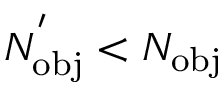<formula> <loc_0><loc_0><loc_500><loc_500>N _ { o b j } ^ { ^ { \prime } } < N _ { o b j }</formula> 